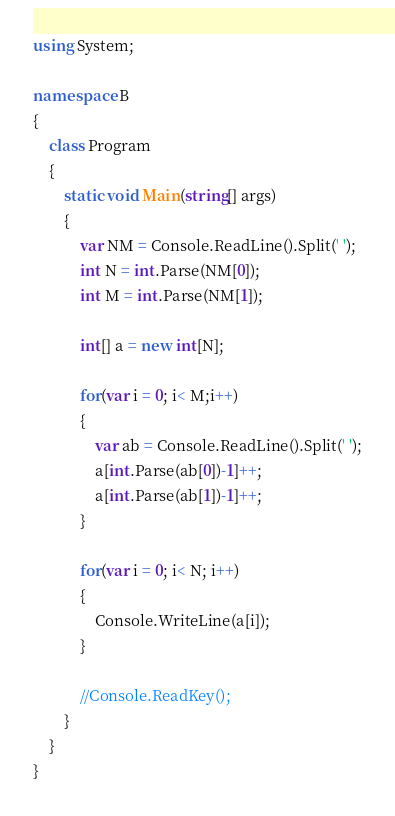<code> <loc_0><loc_0><loc_500><loc_500><_C#_>using System;

namespace B
{
    class Program
    {
        static void Main(string[] args)
        {
            var NM = Console.ReadLine().Split(' ');
            int N = int.Parse(NM[0]);
            int M = int.Parse(NM[1]);

            int[] a = new int[N];

            for(var i = 0; i< M;i++)
            {
                var ab = Console.ReadLine().Split(' ');
                a[int.Parse(ab[0])-1]++;
                a[int.Parse(ab[1])-1]++;
            }

            for(var i = 0; i< N; i++)
            {
                Console.WriteLine(a[i]);
            }

            //Console.ReadKey();
        }
    }
}
</code> 